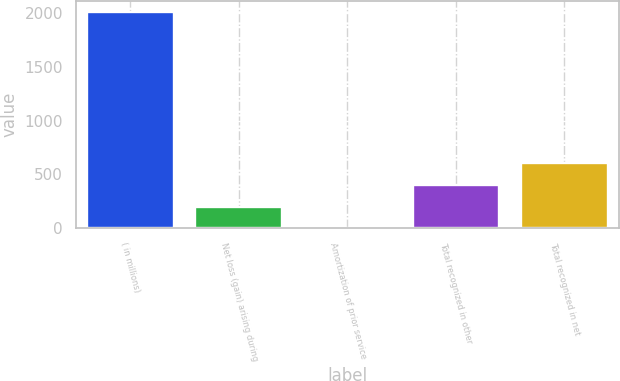<chart> <loc_0><loc_0><loc_500><loc_500><bar_chart><fcel>( in millions)<fcel>Net loss (gain) arising during<fcel>Amortization of prior service<fcel>Total recognized in other<fcel>Total recognized in net<nl><fcel>2008<fcel>200.89<fcel>0.1<fcel>401.68<fcel>602.47<nl></chart> 